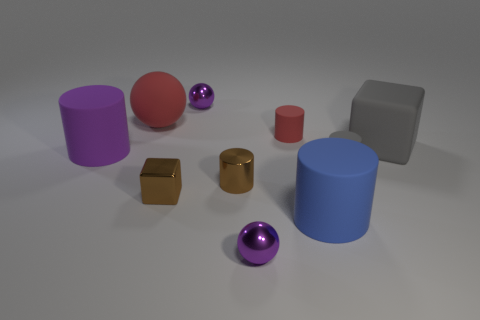Subtract all brown cylinders. How many cylinders are left? 4 Subtract all small brown shiny cylinders. How many cylinders are left? 4 Subtract all cyan cylinders. Subtract all red balls. How many cylinders are left? 5 Subtract all balls. How many objects are left? 7 Add 6 tiny yellow matte cubes. How many tiny yellow matte cubes exist? 6 Subtract 0 cyan cylinders. How many objects are left? 10 Subtract all matte cylinders. Subtract all brown objects. How many objects are left? 4 Add 4 red spheres. How many red spheres are left? 5 